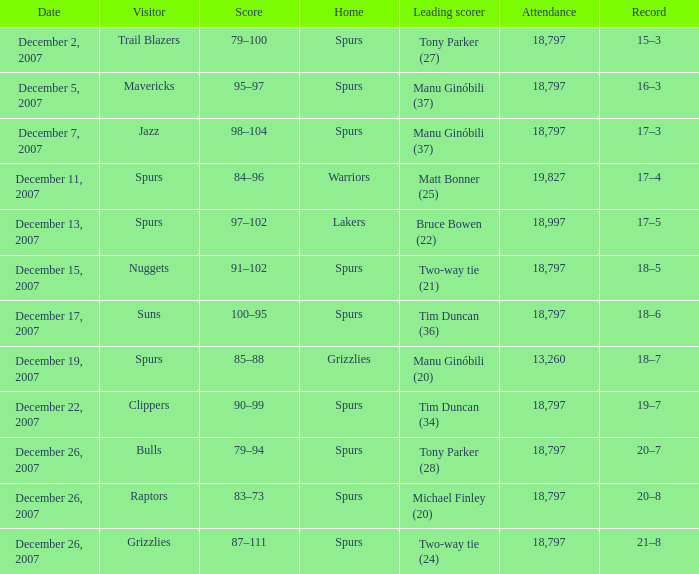What is the record of the game on December 5, 2007? 16–3. 